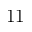Convert formula to latex. <formula><loc_0><loc_0><loc_500><loc_500>1 1</formula> 